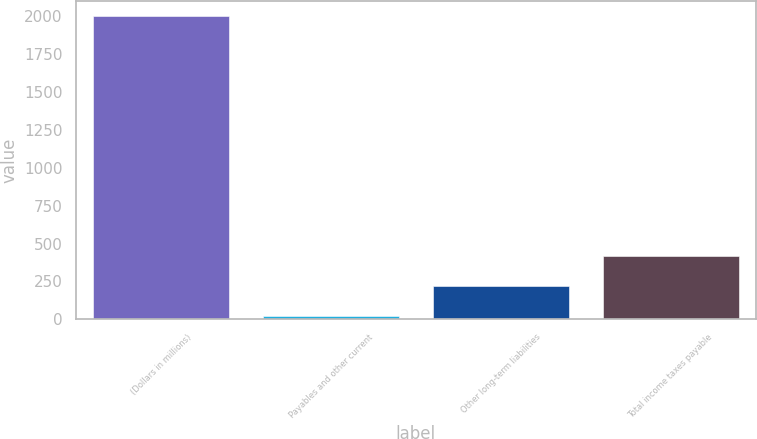<chart> <loc_0><loc_0><loc_500><loc_500><bar_chart><fcel>(Dollars in millions)<fcel>Payables and other current<fcel>Other long-term liabilities<fcel>Total income taxes payable<nl><fcel>2003<fcel>23<fcel>221<fcel>419<nl></chart> 